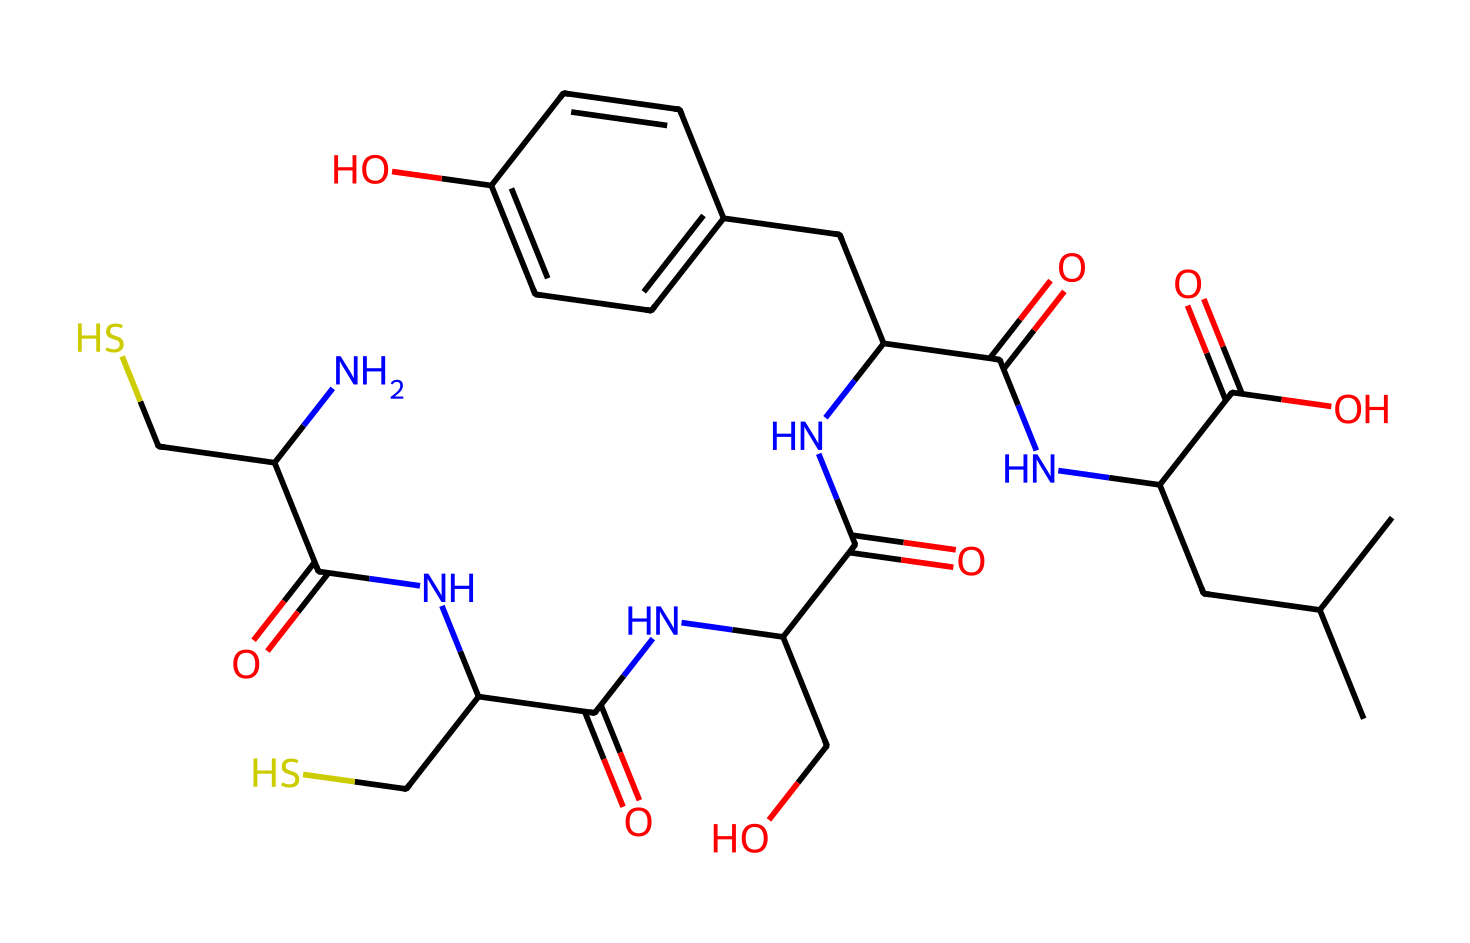What is the molecular weight of this insulin representation? To determine the molecular weight, you would need to sum up the atomic weights of all the atoms represented in the SMILES structure. By analyzing the structure, we find that it consists of several carbon (C), hydrogen (H), nitrogen (N), oxygen (O), and sulfur (S) atoms whose weights we can total to find the molecular weight.
Answer: molecular weight How many nitrogen atoms are present in this structure? By closely analyzing the SMILES representation, we can count the number of nitrogen (N) atoms in the sequence. In this case, there are five NC groups indicated by the presence of "N" in the structure.
Answer: five What functional groups are present in this chemical? The analysis of the SMILES reveals the presence of amides (NC(=O)), hydroxyl groups (C(O)), and a carboxylic acid (C(=O)O). Identifying these groups provides insight into the chemical's reactivity and properties.
Answer: amide, hydroxyl, carboxylic acid What is the effect of insulin on blood sugar levels? Insulin plays a crucial role in regulating blood sugar levels by promoting glucose uptake in cells and inhibiting glucose production in the liver. Its structure allows it to bind to insulin receptors, facilitating these processes.
Answer: lowers blood sugar What type of molecule is insulin classified as? Insulin is classified as a peptide hormone due to its amino acid composition and function in regulating metabolism. The structure derived from SMILES indicates a protein-like nature, supporting this classification.
Answer: peptide hormone 